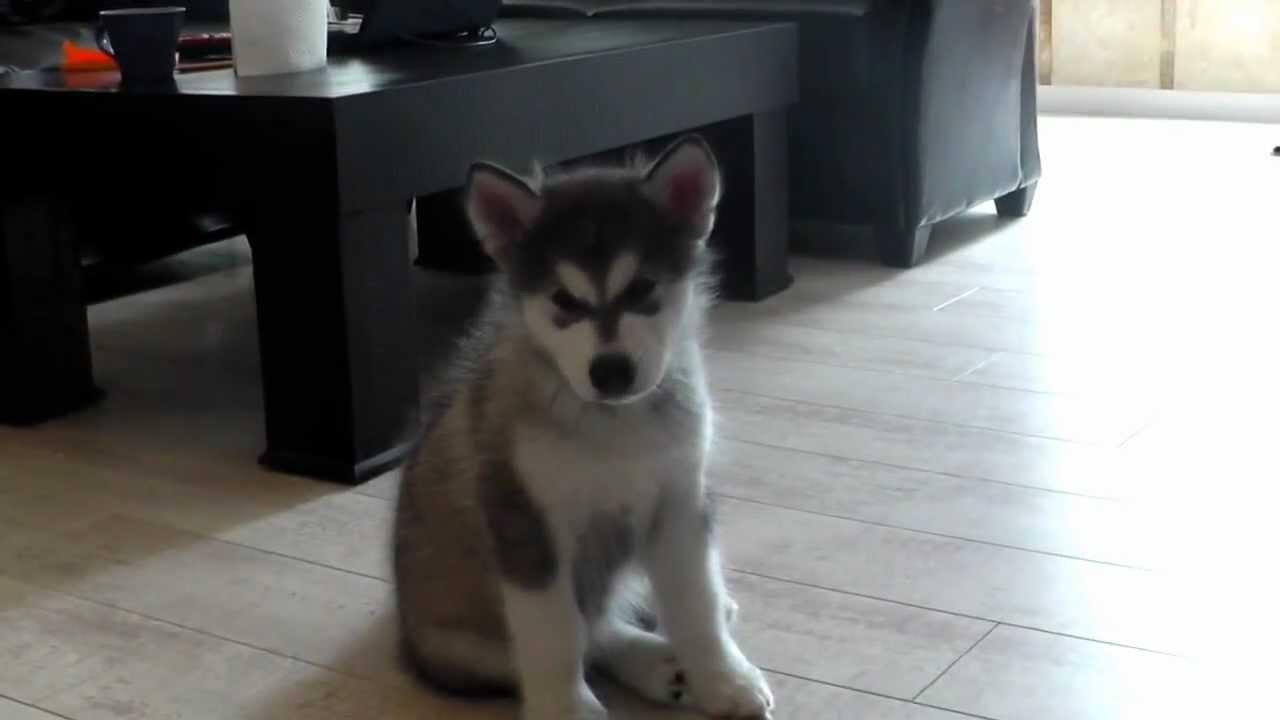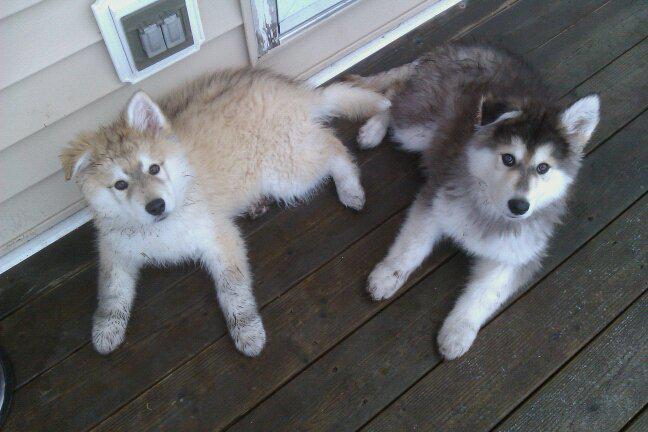The first image is the image on the left, the second image is the image on the right. Evaluate the accuracy of this statement regarding the images: "There are exactly three dogs in total.". Is it true? Answer yes or no. Yes. The first image is the image on the left, the second image is the image on the right. Evaluate the accuracy of this statement regarding the images: "The left and right image contains the same number of dogs.". Is it true? Answer yes or no. No. 